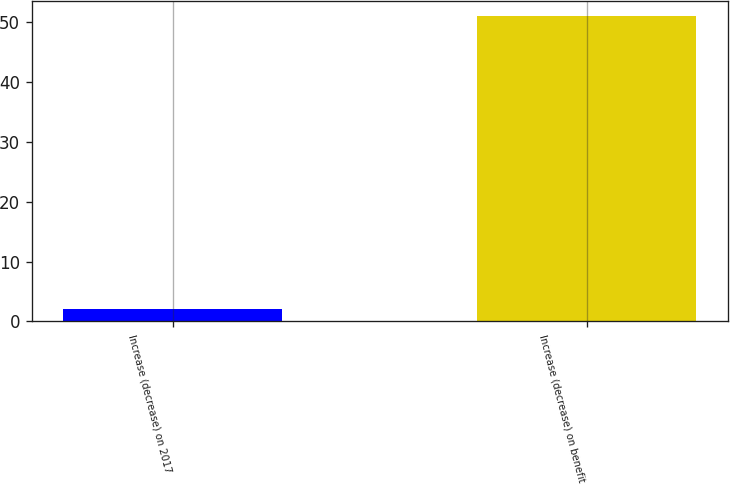Convert chart to OTSL. <chart><loc_0><loc_0><loc_500><loc_500><bar_chart><fcel>Increase (decrease) on 2017<fcel>Increase (decrease) on benefit<nl><fcel>2<fcel>51<nl></chart> 